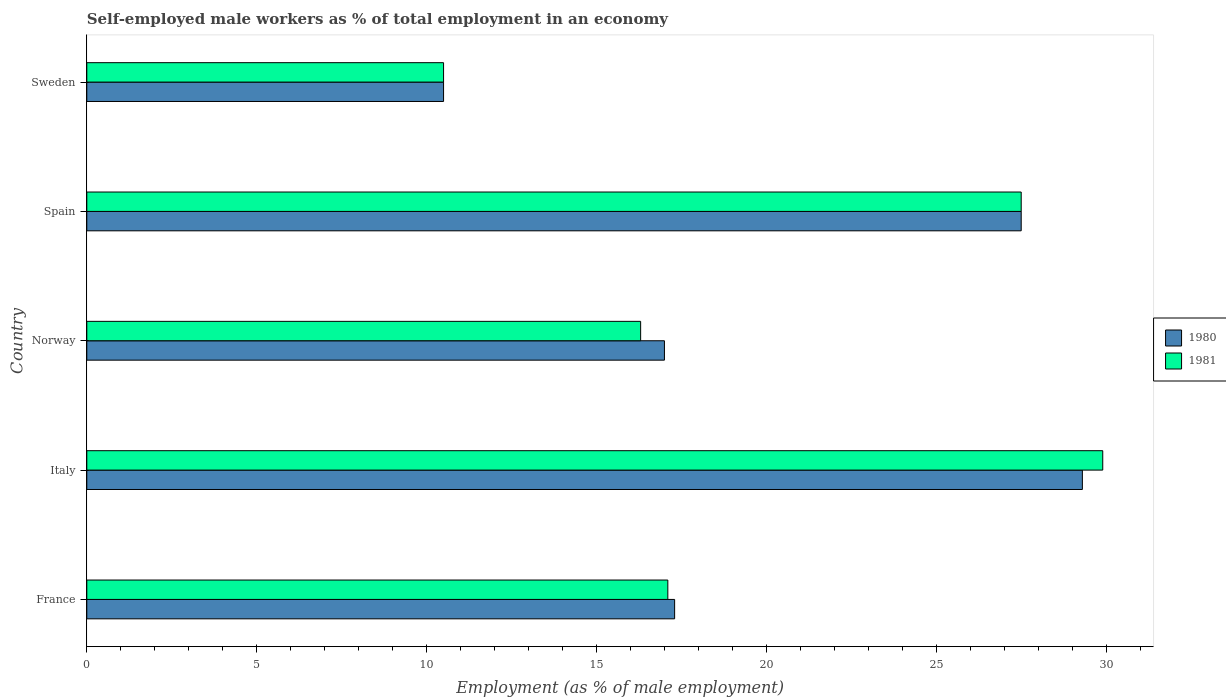How many groups of bars are there?
Keep it short and to the point. 5. How many bars are there on the 2nd tick from the bottom?
Provide a short and direct response. 2. What is the label of the 2nd group of bars from the top?
Make the answer very short. Spain. In how many cases, is the number of bars for a given country not equal to the number of legend labels?
Make the answer very short. 0. What is the percentage of self-employed male workers in 1981 in France?
Provide a short and direct response. 17.1. Across all countries, what is the maximum percentage of self-employed male workers in 1981?
Your response must be concise. 29.9. Across all countries, what is the minimum percentage of self-employed male workers in 1981?
Your response must be concise. 10.5. In which country was the percentage of self-employed male workers in 1981 maximum?
Make the answer very short. Italy. In which country was the percentage of self-employed male workers in 1981 minimum?
Keep it short and to the point. Sweden. What is the total percentage of self-employed male workers in 1981 in the graph?
Give a very brief answer. 101.3. What is the difference between the percentage of self-employed male workers in 1980 in Norway and that in Sweden?
Give a very brief answer. 6.5. What is the difference between the percentage of self-employed male workers in 1981 in Sweden and the percentage of self-employed male workers in 1980 in France?
Your answer should be very brief. -6.8. What is the average percentage of self-employed male workers in 1981 per country?
Offer a very short reply. 20.26. What is the difference between the percentage of self-employed male workers in 1981 and percentage of self-employed male workers in 1980 in Italy?
Make the answer very short. 0.6. What is the ratio of the percentage of self-employed male workers in 1981 in Spain to that in Sweden?
Offer a very short reply. 2.62. Is the percentage of self-employed male workers in 1980 in Norway less than that in Sweden?
Keep it short and to the point. No. What is the difference between the highest and the second highest percentage of self-employed male workers in 1980?
Offer a very short reply. 1.8. What is the difference between the highest and the lowest percentage of self-employed male workers in 1981?
Provide a short and direct response. 19.4. What does the 2nd bar from the top in France represents?
Provide a succinct answer. 1980. What does the 1st bar from the bottom in Italy represents?
Make the answer very short. 1980. Are all the bars in the graph horizontal?
Your response must be concise. Yes. What is the difference between two consecutive major ticks on the X-axis?
Your response must be concise. 5. Does the graph contain any zero values?
Your response must be concise. No. Where does the legend appear in the graph?
Your answer should be very brief. Center right. What is the title of the graph?
Provide a succinct answer. Self-employed male workers as % of total employment in an economy. Does "1995" appear as one of the legend labels in the graph?
Make the answer very short. No. What is the label or title of the X-axis?
Give a very brief answer. Employment (as % of male employment). What is the label or title of the Y-axis?
Provide a succinct answer. Country. What is the Employment (as % of male employment) of 1980 in France?
Keep it short and to the point. 17.3. What is the Employment (as % of male employment) of 1981 in France?
Your response must be concise. 17.1. What is the Employment (as % of male employment) in 1980 in Italy?
Make the answer very short. 29.3. What is the Employment (as % of male employment) in 1981 in Italy?
Offer a very short reply. 29.9. What is the Employment (as % of male employment) in 1980 in Norway?
Ensure brevity in your answer.  17. What is the Employment (as % of male employment) in 1981 in Norway?
Your response must be concise. 16.3. What is the Employment (as % of male employment) of 1980 in Spain?
Provide a succinct answer. 27.5. What is the Employment (as % of male employment) in 1981 in Spain?
Keep it short and to the point. 27.5. What is the Employment (as % of male employment) of 1980 in Sweden?
Give a very brief answer. 10.5. What is the Employment (as % of male employment) in 1981 in Sweden?
Your response must be concise. 10.5. Across all countries, what is the maximum Employment (as % of male employment) in 1980?
Give a very brief answer. 29.3. Across all countries, what is the maximum Employment (as % of male employment) of 1981?
Keep it short and to the point. 29.9. Across all countries, what is the minimum Employment (as % of male employment) in 1981?
Give a very brief answer. 10.5. What is the total Employment (as % of male employment) in 1980 in the graph?
Provide a short and direct response. 101.6. What is the total Employment (as % of male employment) in 1981 in the graph?
Ensure brevity in your answer.  101.3. What is the difference between the Employment (as % of male employment) of 1981 in France and that in Norway?
Offer a terse response. 0.8. What is the difference between the Employment (as % of male employment) in 1981 in France and that in Spain?
Make the answer very short. -10.4. What is the difference between the Employment (as % of male employment) in 1981 in France and that in Sweden?
Give a very brief answer. 6.6. What is the difference between the Employment (as % of male employment) of 1981 in Italy and that in Norway?
Provide a short and direct response. 13.6. What is the difference between the Employment (as % of male employment) in 1980 in Italy and that in Spain?
Ensure brevity in your answer.  1.8. What is the difference between the Employment (as % of male employment) in 1981 in Italy and that in Spain?
Ensure brevity in your answer.  2.4. What is the difference between the Employment (as % of male employment) of 1980 in Italy and that in Sweden?
Your answer should be compact. 18.8. What is the difference between the Employment (as % of male employment) in 1981 in Italy and that in Sweden?
Offer a terse response. 19.4. What is the difference between the Employment (as % of male employment) in 1980 in Norway and that in Spain?
Make the answer very short. -10.5. What is the difference between the Employment (as % of male employment) in 1981 in Norway and that in Spain?
Provide a succinct answer. -11.2. What is the difference between the Employment (as % of male employment) of 1980 in Spain and that in Sweden?
Keep it short and to the point. 17. What is the difference between the Employment (as % of male employment) of 1981 in Spain and that in Sweden?
Offer a terse response. 17. What is the difference between the Employment (as % of male employment) in 1980 in France and the Employment (as % of male employment) in 1981 in Italy?
Ensure brevity in your answer.  -12.6. What is the difference between the Employment (as % of male employment) of 1980 in France and the Employment (as % of male employment) of 1981 in Spain?
Your answer should be very brief. -10.2. What is the difference between the Employment (as % of male employment) in 1980 in France and the Employment (as % of male employment) in 1981 in Sweden?
Provide a succinct answer. 6.8. What is the difference between the Employment (as % of male employment) of 1980 in Italy and the Employment (as % of male employment) of 1981 in Norway?
Your answer should be very brief. 13. What is the difference between the Employment (as % of male employment) in 1980 in Italy and the Employment (as % of male employment) in 1981 in Spain?
Keep it short and to the point. 1.8. What is the difference between the Employment (as % of male employment) of 1980 in Italy and the Employment (as % of male employment) of 1981 in Sweden?
Give a very brief answer. 18.8. What is the difference between the Employment (as % of male employment) of 1980 in Norway and the Employment (as % of male employment) of 1981 in Spain?
Offer a very short reply. -10.5. What is the difference between the Employment (as % of male employment) of 1980 in Norway and the Employment (as % of male employment) of 1981 in Sweden?
Offer a very short reply. 6.5. What is the difference between the Employment (as % of male employment) of 1980 in Spain and the Employment (as % of male employment) of 1981 in Sweden?
Give a very brief answer. 17. What is the average Employment (as % of male employment) in 1980 per country?
Keep it short and to the point. 20.32. What is the average Employment (as % of male employment) in 1981 per country?
Your answer should be very brief. 20.26. What is the difference between the Employment (as % of male employment) in 1980 and Employment (as % of male employment) in 1981 in Italy?
Make the answer very short. -0.6. What is the ratio of the Employment (as % of male employment) in 1980 in France to that in Italy?
Offer a terse response. 0.59. What is the ratio of the Employment (as % of male employment) in 1981 in France to that in Italy?
Your answer should be very brief. 0.57. What is the ratio of the Employment (as % of male employment) in 1980 in France to that in Norway?
Provide a succinct answer. 1.02. What is the ratio of the Employment (as % of male employment) in 1981 in France to that in Norway?
Give a very brief answer. 1.05. What is the ratio of the Employment (as % of male employment) of 1980 in France to that in Spain?
Offer a terse response. 0.63. What is the ratio of the Employment (as % of male employment) of 1981 in France to that in Spain?
Make the answer very short. 0.62. What is the ratio of the Employment (as % of male employment) of 1980 in France to that in Sweden?
Your answer should be very brief. 1.65. What is the ratio of the Employment (as % of male employment) of 1981 in France to that in Sweden?
Ensure brevity in your answer.  1.63. What is the ratio of the Employment (as % of male employment) of 1980 in Italy to that in Norway?
Offer a very short reply. 1.72. What is the ratio of the Employment (as % of male employment) of 1981 in Italy to that in Norway?
Your answer should be compact. 1.83. What is the ratio of the Employment (as % of male employment) of 1980 in Italy to that in Spain?
Keep it short and to the point. 1.07. What is the ratio of the Employment (as % of male employment) of 1981 in Italy to that in Spain?
Offer a terse response. 1.09. What is the ratio of the Employment (as % of male employment) in 1980 in Italy to that in Sweden?
Offer a very short reply. 2.79. What is the ratio of the Employment (as % of male employment) in 1981 in Italy to that in Sweden?
Give a very brief answer. 2.85. What is the ratio of the Employment (as % of male employment) of 1980 in Norway to that in Spain?
Your response must be concise. 0.62. What is the ratio of the Employment (as % of male employment) in 1981 in Norway to that in Spain?
Offer a very short reply. 0.59. What is the ratio of the Employment (as % of male employment) of 1980 in Norway to that in Sweden?
Your answer should be compact. 1.62. What is the ratio of the Employment (as % of male employment) in 1981 in Norway to that in Sweden?
Your response must be concise. 1.55. What is the ratio of the Employment (as % of male employment) in 1980 in Spain to that in Sweden?
Offer a very short reply. 2.62. What is the ratio of the Employment (as % of male employment) in 1981 in Spain to that in Sweden?
Provide a short and direct response. 2.62. What is the difference between the highest and the second highest Employment (as % of male employment) of 1980?
Ensure brevity in your answer.  1.8. What is the difference between the highest and the second highest Employment (as % of male employment) of 1981?
Make the answer very short. 2.4. What is the difference between the highest and the lowest Employment (as % of male employment) in 1980?
Your response must be concise. 18.8. What is the difference between the highest and the lowest Employment (as % of male employment) of 1981?
Give a very brief answer. 19.4. 